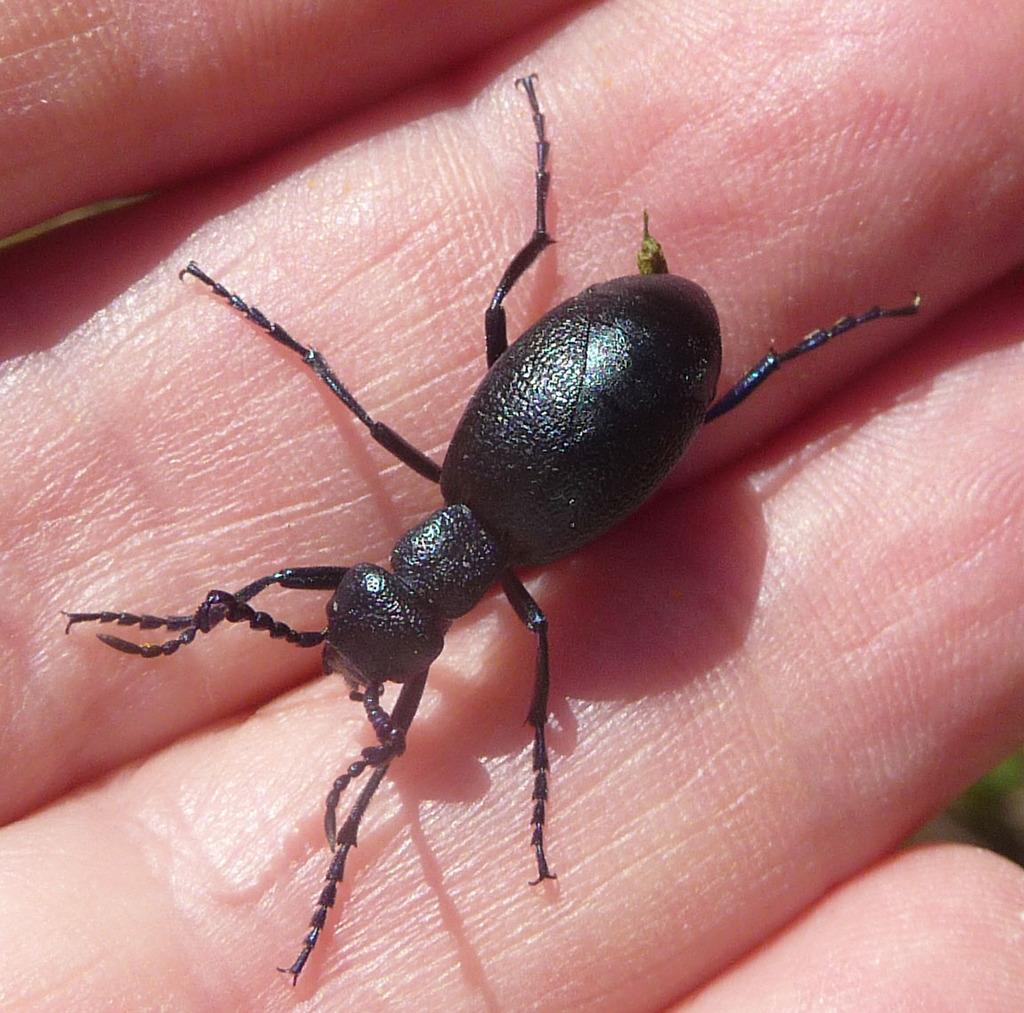Could you give a brief overview of what you see in this image? In this image we can see an insect on the fingers of a person. 